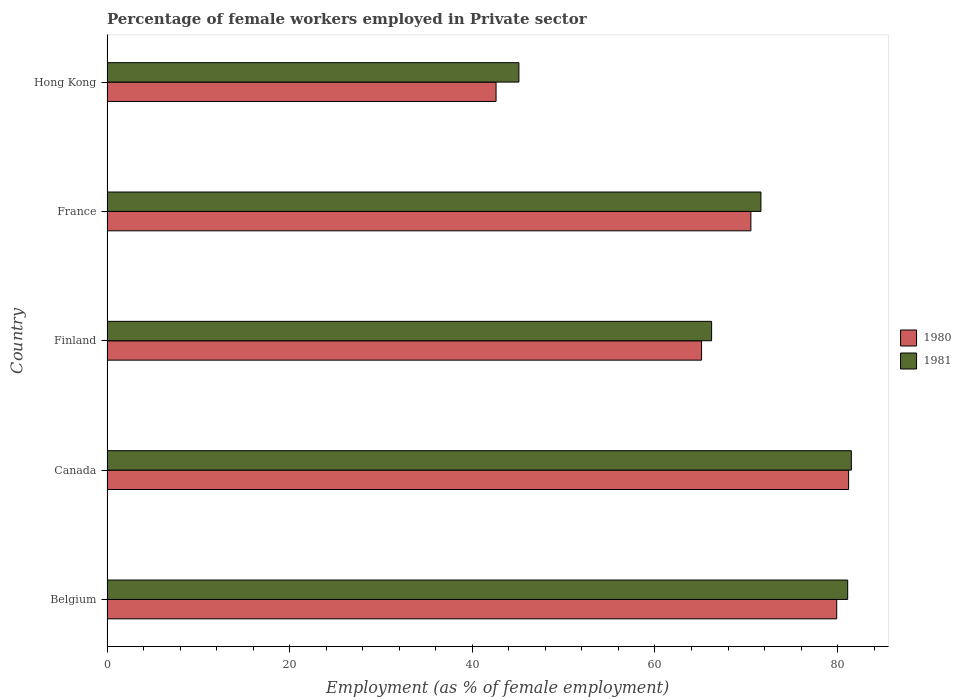How many different coloured bars are there?
Keep it short and to the point. 2. How many groups of bars are there?
Your answer should be compact. 5. Are the number of bars on each tick of the Y-axis equal?
Provide a short and direct response. Yes. What is the label of the 4th group of bars from the top?
Your answer should be very brief. Canada. In how many cases, is the number of bars for a given country not equal to the number of legend labels?
Provide a succinct answer. 0. What is the percentage of females employed in Private sector in 1980 in Canada?
Your answer should be compact. 81.2. Across all countries, what is the maximum percentage of females employed in Private sector in 1981?
Offer a very short reply. 81.5. Across all countries, what is the minimum percentage of females employed in Private sector in 1981?
Ensure brevity in your answer.  45.1. In which country was the percentage of females employed in Private sector in 1981 minimum?
Your answer should be compact. Hong Kong. What is the total percentage of females employed in Private sector in 1980 in the graph?
Provide a succinct answer. 339.3. What is the difference between the percentage of females employed in Private sector in 1981 in Finland and that in France?
Offer a very short reply. -5.4. What is the difference between the percentage of females employed in Private sector in 1980 in Belgium and the percentage of females employed in Private sector in 1981 in France?
Your response must be concise. 8.3. What is the average percentage of females employed in Private sector in 1980 per country?
Offer a terse response. 67.86. In how many countries, is the percentage of females employed in Private sector in 1981 greater than 28 %?
Give a very brief answer. 5. What is the ratio of the percentage of females employed in Private sector in 1980 in Finland to that in Hong Kong?
Keep it short and to the point. 1.53. Is the difference between the percentage of females employed in Private sector in 1981 in Canada and France greater than the difference between the percentage of females employed in Private sector in 1980 in Canada and France?
Keep it short and to the point. No. What is the difference between the highest and the second highest percentage of females employed in Private sector in 1980?
Offer a very short reply. 1.3. What is the difference between the highest and the lowest percentage of females employed in Private sector in 1981?
Ensure brevity in your answer.  36.4. Is the sum of the percentage of females employed in Private sector in 1981 in Belgium and Canada greater than the maximum percentage of females employed in Private sector in 1980 across all countries?
Make the answer very short. Yes. How many bars are there?
Provide a short and direct response. 10. Does the graph contain any zero values?
Ensure brevity in your answer.  No. Does the graph contain grids?
Ensure brevity in your answer.  No. How are the legend labels stacked?
Provide a succinct answer. Vertical. What is the title of the graph?
Offer a very short reply. Percentage of female workers employed in Private sector. What is the label or title of the X-axis?
Your answer should be very brief. Employment (as % of female employment). What is the label or title of the Y-axis?
Give a very brief answer. Country. What is the Employment (as % of female employment) in 1980 in Belgium?
Your response must be concise. 79.9. What is the Employment (as % of female employment) of 1981 in Belgium?
Your response must be concise. 81.1. What is the Employment (as % of female employment) in 1980 in Canada?
Your answer should be compact. 81.2. What is the Employment (as % of female employment) of 1981 in Canada?
Your response must be concise. 81.5. What is the Employment (as % of female employment) in 1980 in Finland?
Make the answer very short. 65.1. What is the Employment (as % of female employment) of 1981 in Finland?
Make the answer very short. 66.2. What is the Employment (as % of female employment) of 1980 in France?
Make the answer very short. 70.5. What is the Employment (as % of female employment) of 1981 in France?
Ensure brevity in your answer.  71.6. What is the Employment (as % of female employment) of 1980 in Hong Kong?
Make the answer very short. 42.6. What is the Employment (as % of female employment) of 1981 in Hong Kong?
Offer a very short reply. 45.1. Across all countries, what is the maximum Employment (as % of female employment) in 1980?
Ensure brevity in your answer.  81.2. Across all countries, what is the maximum Employment (as % of female employment) of 1981?
Make the answer very short. 81.5. Across all countries, what is the minimum Employment (as % of female employment) of 1980?
Your answer should be compact. 42.6. Across all countries, what is the minimum Employment (as % of female employment) in 1981?
Ensure brevity in your answer.  45.1. What is the total Employment (as % of female employment) in 1980 in the graph?
Your answer should be compact. 339.3. What is the total Employment (as % of female employment) of 1981 in the graph?
Give a very brief answer. 345.5. What is the difference between the Employment (as % of female employment) in 1980 in Belgium and that in France?
Offer a very short reply. 9.4. What is the difference between the Employment (as % of female employment) of 1980 in Belgium and that in Hong Kong?
Your answer should be very brief. 37.3. What is the difference between the Employment (as % of female employment) of 1981 in Belgium and that in Hong Kong?
Your answer should be very brief. 36. What is the difference between the Employment (as % of female employment) of 1980 in Canada and that in Finland?
Offer a very short reply. 16.1. What is the difference between the Employment (as % of female employment) in 1981 in Canada and that in Finland?
Your answer should be very brief. 15.3. What is the difference between the Employment (as % of female employment) of 1980 in Canada and that in Hong Kong?
Your answer should be very brief. 38.6. What is the difference between the Employment (as % of female employment) in 1981 in Canada and that in Hong Kong?
Your response must be concise. 36.4. What is the difference between the Employment (as % of female employment) of 1981 in Finland and that in Hong Kong?
Your response must be concise. 21.1. What is the difference between the Employment (as % of female employment) in 1980 in France and that in Hong Kong?
Make the answer very short. 27.9. What is the difference between the Employment (as % of female employment) in 1980 in Belgium and the Employment (as % of female employment) in 1981 in France?
Provide a succinct answer. 8.3. What is the difference between the Employment (as % of female employment) in 1980 in Belgium and the Employment (as % of female employment) in 1981 in Hong Kong?
Your response must be concise. 34.8. What is the difference between the Employment (as % of female employment) in 1980 in Canada and the Employment (as % of female employment) in 1981 in Finland?
Your answer should be compact. 15. What is the difference between the Employment (as % of female employment) in 1980 in Canada and the Employment (as % of female employment) in 1981 in France?
Give a very brief answer. 9.6. What is the difference between the Employment (as % of female employment) of 1980 in Canada and the Employment (as % of female employment) of 1981 in Hong Kong?
Give a very brief answer. 36.1. What is the difference between the Employment (as % of female employment) in 1980 in Finland and the Employment (as % of female employment) in 1981 in France?
Keep it short and to the point. -6.5. What is the difference between the Employment (as % of female employment) of 1980 in Finland and the Employment (as % of female employment) of 1981 in Hong Kong?
Ensure brevity in your answer.  20. What is the difference between the Employment (as % of female employment) in 1980 in France and the Employment (as % of female employment) in 1981 in Hong Kong?
Give a very brief answer. 25.4. What is the average Employment (as % of female employment) in 1980 per country?
Your answer should be very brief. 67.86. What is the average Employment (as % of female employment) of 1981 per country?
Keep it short and to the point. 69.1. What is the difference between the Employment (as % of female employment) of 1980 and Employment (as % of female employment) of 1981 in France?
Provide a short and direct response. -1.1. What is the ratio of the Employment (as % of female employment) in 1981 in Belgium to that in Canada?
Offer a very short reply. 1. What is the ratio of the Employment (as % of female employment) of 1980 in Belgium to that in Finland?
Ensure brevity in your answer.  1.23. What is the ratio of the Employment (as % of female employment) in 1981 in Belgium to that in Finland?
Ensure brevity in your answer.  1.23. What is the ratio of the Employment (as % of female employment) in 1980 in Belgium to that in France?
Your response must be concise. 1.13. What is the ratio of the Employment (as % of female employment) in 1981 in Belgium to that in France?
Give a very brief answer. 1.13. What is the ratio of the Employment (as % of female employment) in 1980 in Belgium to that in Hong Kong?
Give a very brief answer. 1.88. What is the ratio of the Employment (as % of female employment) of 1981 in Belgium to that in Hong Kong?
Make the answer very short. 1.8. What is the ratio of the Employment (as % of female employment) in 1980 in Canada to that in Finland?
Provide a short and direct response. 1.25. What is the ratio of the Employment (as % of female employment) in 1981 in Canada to that in Finland?
Keep it short and to the point. 1.23. What is the ratio of the Employment (as % of female employment) in 1980 in Canada to that in France?
Give a very brief answer. 1.15. What is the ratio of the Employment (as % of female employment) in 1981 in Canada to that in France?
Ensure brevity in your answer.  1.14. What is the ratio of the Employment (as % of female employment) of 1980 in Canada to that in Hong Kong?
Your answer should be compact. 1.91. What is the ratio of the Employment (as % of female employment) of 1981 in Canada to that in Hong Kong?
Offer a terse response. 1.81. What is the ratio of the Employment (as % of female employment) in 1980 in Finland to that in France?
Offer a very short reply. 0.92. What is the ratio of the Employment (as % of female employment) in 1981 in Finland to that in France?
Provide a succinct answer. 0.92. What is the ratio of the Employment (as % of female employment) of 1980 in Finland to that in Hong Kong?
Offer a very short reply. 1.53. What is the ratio of the Employment (as % of female employment) of 1981 in Finland to that in Hong Kong?
Make the answer very short. 1.47. What is the ratio of the Employment (as % of female employment) of 1980 in France to that in Hong Kong?
Your answer should be very brief. 1.65. What is the ratio of the Employment (as % of female employment) of 1981 in France to that in Hong Kong?
Your answer should be compact. 1.59. What is the difference between the highest and the second highest Employment (as % of female employment) of 1980?
Ensure brevity in your answer.  1.3. What is the difference between the highest and the lowest Employment (as % of female employment) in 1980?
Offer a terse response. 38.6. What is the difference between the highest and the lowest Employment (as % of female employment) of 1981?
Provide a succinct answer. 36.4. 